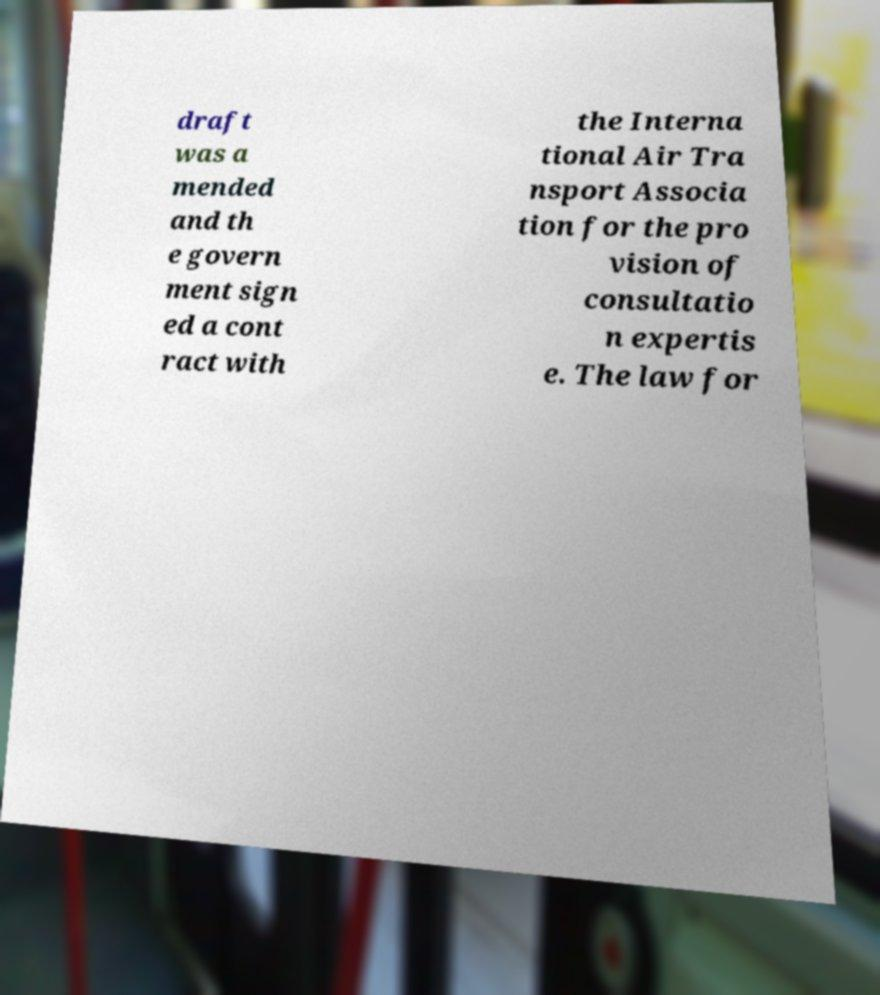Could you assist in decoding the text presented in this image and type it out clearly? draft was a mended and th e govern ment sign ed a cont ract with the Interna tional Air Tra nsport Associa tion for the pro vision of consultatio n expertis e. The law for 